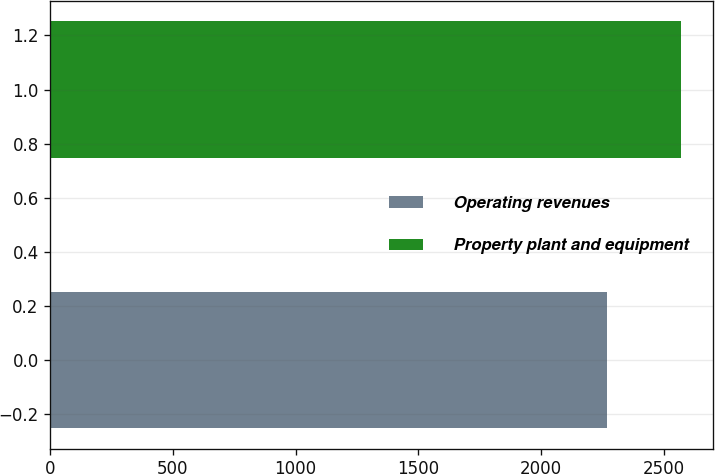<chart> <loc_0><loc_0><loc_500><loc_500><bar_chart><fcel>Operating revenues<fcel>Property plant and equipment<nl><fcel>2271<fcel>2573<nl></chart> 